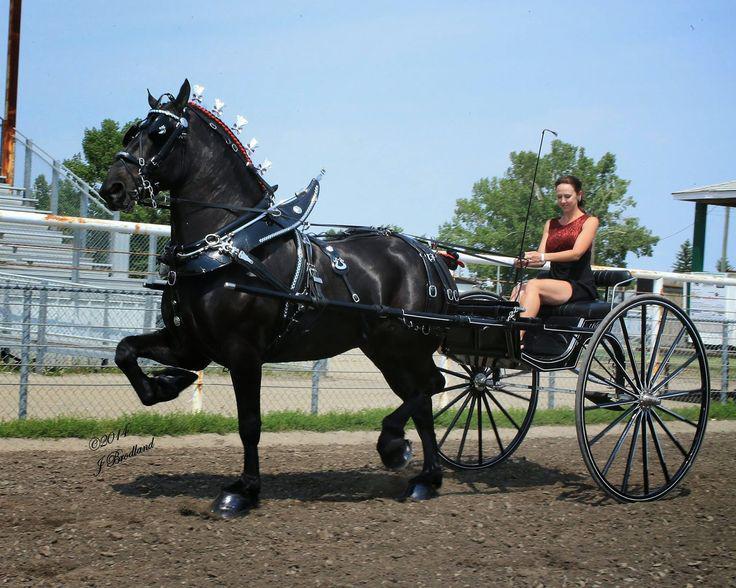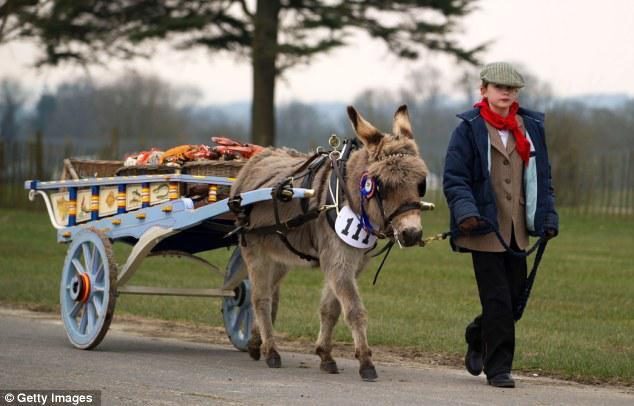The first image is the image on the left, the second image is the image on the right. Examine the images to the left and right. Is the description "At least one wagon is carrying more than one person." accurate? Answer yes or no. No. The first image is the image on the left, the second image is the image on the right. For the images shown, is this caption "The carriages are being pulled by brown horses." true? Answer yes or no. No. 